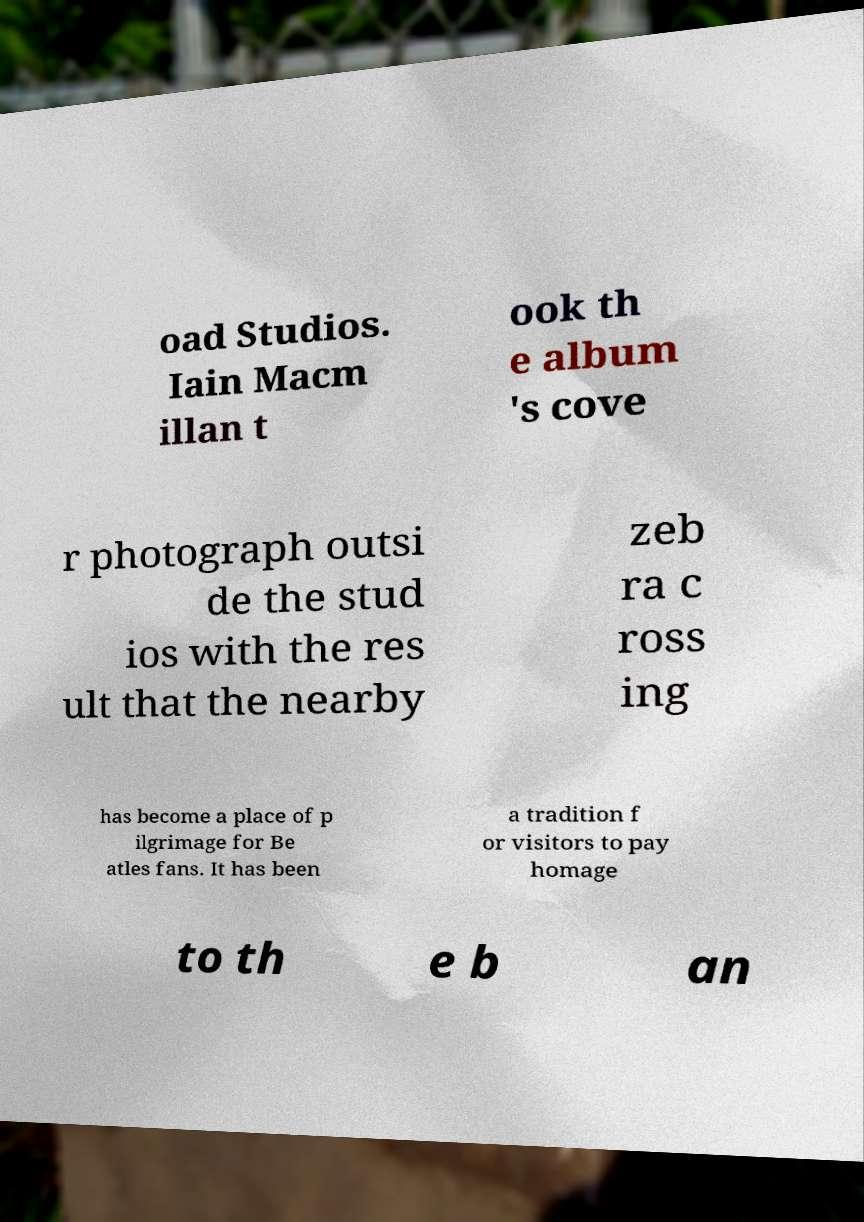Could you extract and type out the text from this image? oad Studios. Iain Macm illan t ook th e album 's cove r photograph outsi de the stud ios with the res ult that the nearby zeb ra c ross ing has become a place of p ilgrimage for Be atles fans. It has been a tradition f or visitors to pay homage to th e b an 